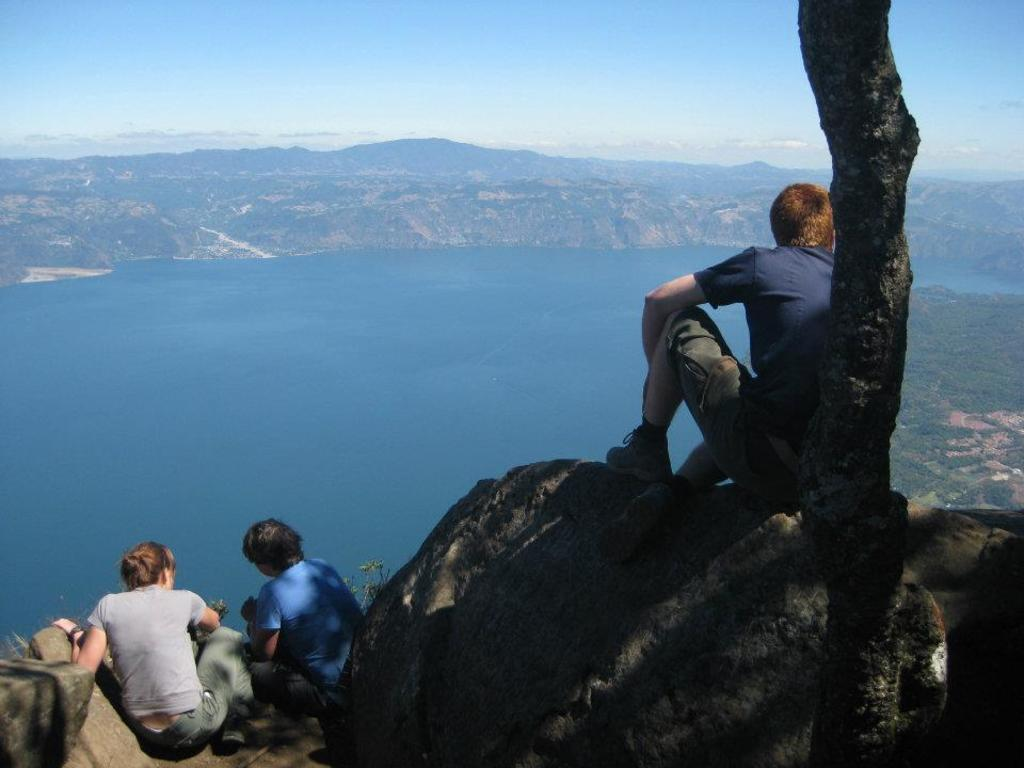How many people are sitting in the image? There are three people sitting in the image. What can be seen in the image besides the people? There is a tree trunk, water, a hill, and the sky visible in the image. Can you describe the background of the image? The background of the image includes water, a hill, and the sky. What is the position of the tree trunk in the image? The tree trunk is in the image, but its exact position cannot be determined without more information. What type of rhythm is the water creating in the image? The water in the image is not creating a rhythm; it is simply visible in the background. 